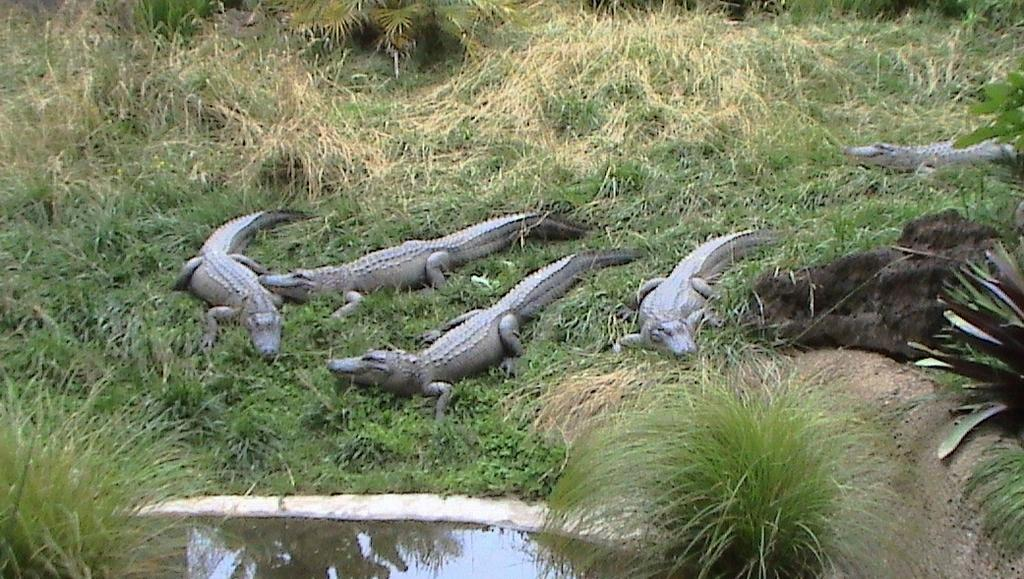What is present at the bottom of the image? There is water at the bottom of the image. What can be seen in the background of the image? There are plants and grass in the background of the image. What animals are in the middle of the image? There are alligators in the middle of the image. Where is the mailbox located in the image? There is no mailbox present in the image. What type of fruit is hanging from the plants in the image? There is no fruit mentioned in the image, only plants and grass are described in the background. 